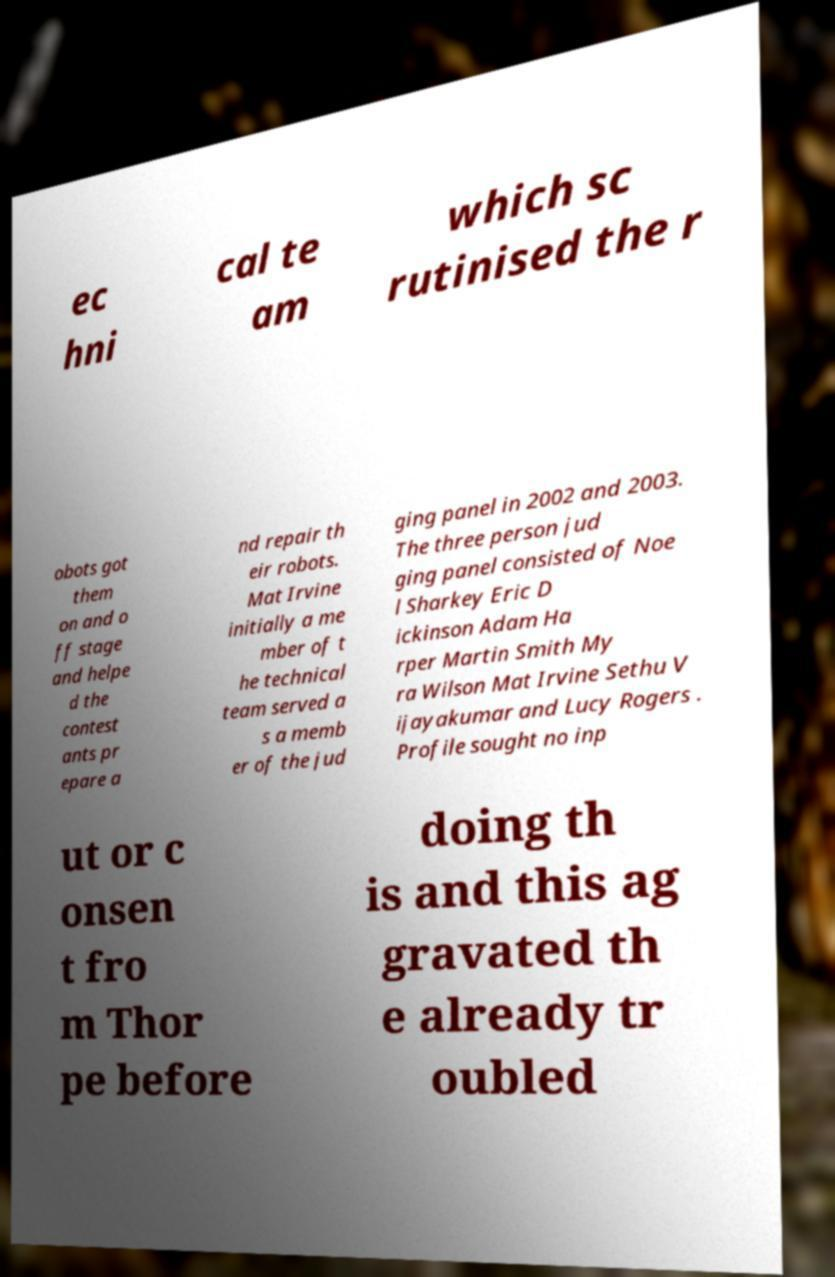Could you extract and type out the text from this image? ec hni cal te am which sc rutinised the r obots got them on and o ff stage and helpe d the contest ants pr epare a nd repair th eir robots. Mat Irvine initially a me mber of t he technical team served a s a memb er of the jud ging panel in 2002 and 2003. The three person jud ging panel consisted of Noe l Sharkey Eric D ickinson Adam Ha rper Martin Smith My ra Wilson Mat Irvine Sethu V ijayakumar and Lucy Rogers . Profile sought no inp ut or c onsen t fro m Thor pe before doing th is and this ag gravated th e already tr oubled 